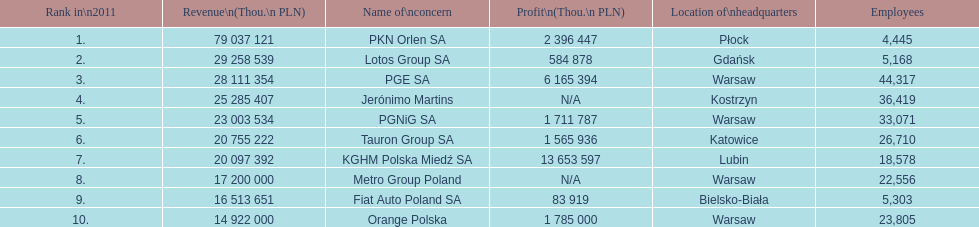What is the difference in employees for rank 1 and rank 3? 39,872 employees. 